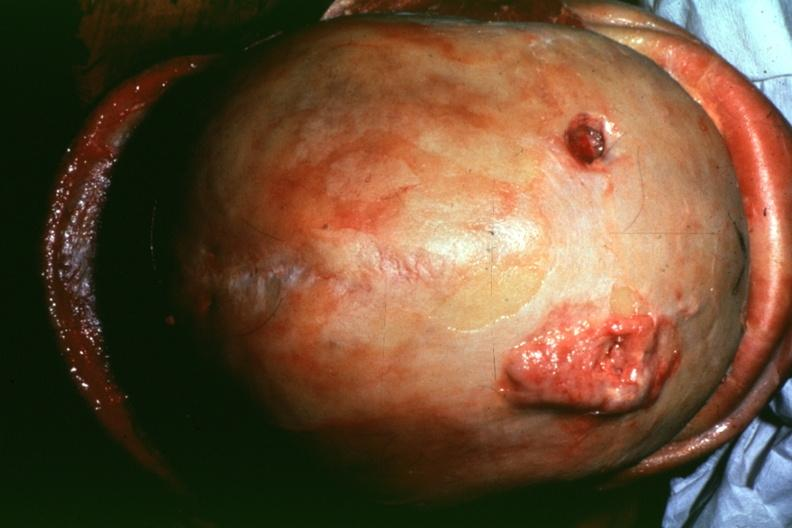what is present?
Answer the question using a single word or phrase. Metastatic lung carcinoma 